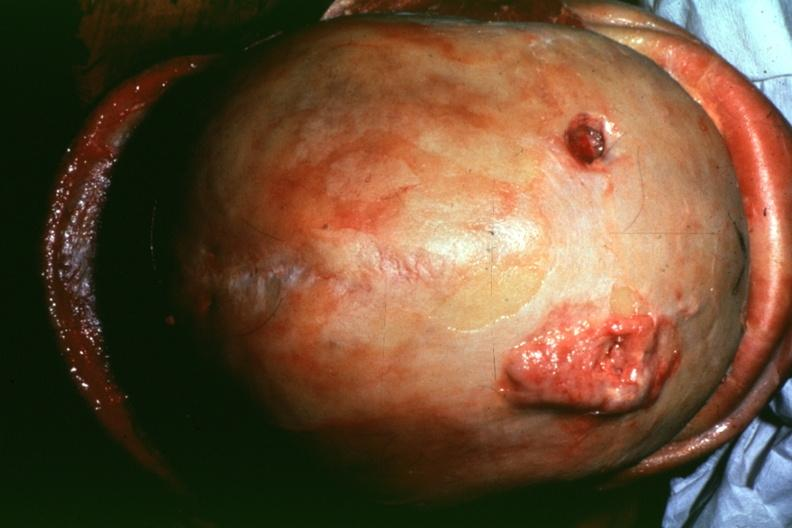what is present?
Answer the question using a single word or phrase. Metastatic lung carcinoma 